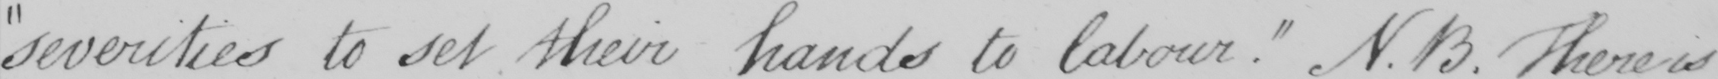Can you tell me what this handwritten text says? severities to set their hands to labour . N.B . There is 